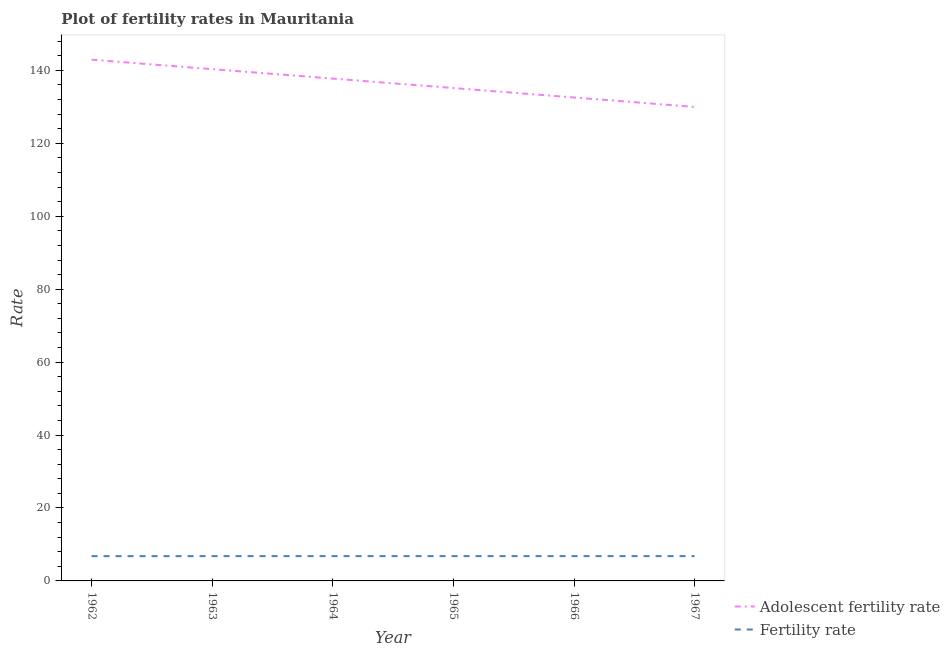Is the number of lines equal to the number of legend labels?
Ensure brevity in your answer.  Yes. What is the adolescent fertility rate in 1966?
Offer a terse response. 132.57. Across all years, what is the maximum fertility rate?
Give a very brief answer. 6.8. Across all years, what is the minimum fertility rate?
Your answer should be compact. 6.79. In which year was the adolescent fertility rate maximum?
Your answer should be compact. 1962. In which year was the adolescent fertility rate minimum?
Provide a succinct answer. 1967. What is the total adolescent fertility rate in the graph?
Your response must be concise. 818.74. What is the difference between the adolescent fertility rate in 1962 and that in 1963?
Make the answer very short. 2.59. What is the difference between the fertility rate in 1967 and the adolescent fertility rate in 1962?
Your answer should be very brief. -136.13. What is the average fertility rate per year?
Offer a terse response. 6.8. In the year 1962, what is the difference between the fertility rate and adolescent fertility rate?
Make the answer very short. -136.14. What is the ratio of the fertility rate in 1962 to that in 1963?
Your response must be concise. 1. What is the difference between the highest and the second highest fertility rate?
Your answer should be compact. 0. What is the difference between the highest and the lowest fertility rate?
Your answer should be compact. 0.01. Is the adolescent fertility rate strictly less than the fertility rate over the years?
Provide a short and direct response. No. How many years are there in the graph?
Your response must be concise. 6. Are the values on the major ticks of Y-axis written in scientific E-notation?
Give a very brief answer. No. Does the graph contain any zero values?
Offer a very short reply. No. Where does the legend appear in the graph?
Keep it short and to the point. Bottom right. What is the title of the graph?
Provide a succinct answer. Plot of fertility rates in Mauritania. Does "National Visitors" appear as one of the legend labels in the graph?
Provide a succinct answer. No. What is the label or title of the Y-axis?
Provide a short and direct response. Rate. What is the Rate of Adolescent fertility rate in 1962?
Make the answer very short. 142.93. What is the Rate in Fertility rate in 1962?
Provide a succinct answer. 6.79. What is the Rate in Adolescent fertility rate in 1963?
Keep it short and to the point. 140.34. What is the Rate of Fertility rate in 1963?
Offer a very short reply. 6.8. What is the Rate in Adolescent fertility rate in 1964?
Ensure brevity in your answer.  137.75. What is the Rate of Fertility rate in 1964?
Provide a succinct answer. 6.8. What is the Rate of Adolescent fertility rate in 1965?
Provide a succinct answer. 135.16. What is the Rate in Fertility rate in 1965?
Provide a succinct answer. 6.8. What is the Rate in Adolescent fertility rate in 1966?
Offer a very short reply. 132.57. What is the Rate in Fertility rate in 1966?
Your answer should be compact. 6.8. What is the Rate in Adolescent fertility rate in 1967?
Ensure brevity in your answer.  129.98. What is the Rate of Fertility rate in 1967?
Your response must be concise. 6.8. Across all years, what is the maximum Rate in Adolescent fertility rate?
Your answer should be compact. 142.93. Across all years, what is the maximum Rate in Fertility rate?
Your response must be concise. 6.8. Across all years, what is the minimum Rate of Adolescent fertility rate?
Offer a terse response. 129.98. Across all years, what is the minimum Rate in Fertility rate?
Give a very brief answer. 6.79. What is the total Rate in Adolescent fertility rate in the graph?
Offer a very short reply. 818.74. What is the total Rate in Fertility rate in the graph?
Keep it short and to the point. 40.79. What is the difference between the Rate of Adolescent fertility rate in 1962 and that in 1963?
Make the answer very short. 2.59. What is the difference between the Rate in Fertility rate in 1962 and that in 1963?
Provide a short and direct response. -0. What is the difference between the Rate of Adolescent fertility rate in 1962 and that in 1964?
Ensure brevity in your answer.  5.18. What is the difference between the Rate of Fertility rate in 1962 and that in 1964?
Provide a short and direct response. -0.01. What is the difference between the Rate in Adolescent fertility rate in 1962 and that in 1965?
Provide a short and direct response. 7.77. What is the difference between the Rate in Fertility rate in 1962 and that in 1965?
Your response must be concise. -0.01. What is the difference between the Rate in Adolescent fertility rate in 1962 and that in 1966?
Your answer should be compact. 10.36. What is the difference between the Rate of Fertility rate in 1962 and that in 1966?
Ensure brevity in your answer.  -0. What is the difference between the Rate of Adolescent fertility rate in 1962 and that in 1967?
Make the answer very short. 12.95. What is the difference between the Rate in Fertility rate in 1962 and that in 1967?
Offer a terse response. -0. What is the difference between the Rate in Adolescent fertility rate in 1963 and that in 1964?
Offer a terse response. 2.59. What is the difference between the Rate in Fertility rate in 1963 and that in 1964?
Keep it short and to the point. -0. What is the difference between the Rate of Adolescent fertility rate in 1963 and that in 1965?
Ensure brevity in your answer.  5.18. What is the difference between the Rate in Fertility rate in 1963 and that in 1965?
Give a very brief answer. -0. What is the difference between the Rate of Adolescent fertility rate in 1963 and that in 1966?
Provide a succinct answer. 7.77. What is the difference between the Rate in Adolescent fertility rate in 1963 and that in 1967?
Ensure brevity in your answer.  10.36. What is the difference between the Rate in Adolescent fertility rate in 1964 and that in 1965?
Your answer should be very brief. 2.59. What is the difference between the Rate in Fertility rate in 1964 and that in 1965?
Your response must be concise. 0. What is the difference between the Rate in Adolescent fertility rate in 1964 and that in 1966?
Your answer should be very brief. 5.18. What is the difference between the Rate in Fertility rate in 1964 and that in 1966?
Make the answer very short. 0. What is the difference between the Rate in Adolescent fertility rate in 1964 and that in 1967?
Your answer should be compact. 7.77. What is the difference between the Rate of Adolescent fertility rate in 1965 and that in 1966?
Offer a terse response. 2.59. What is the difference between the Rate in Fertility rate in 1965 and that in 1966?
Keep it short and to the point. 0. What is the difference between the Rate in Adolescent fertility rate in 1965 and that in 1967?
Offer a terse response. 5.18. What is the difference between the Rate in Adolescent fertility rate in 1966 and that in 1967?
Your response must be concise. 2.59. What is the difference between the Rate of Adolescent fertility rate in 1962 and the Rate of Fertility rate in 1963?
Your answer should be very brief. 136.13. What is the difference between the Rate in Adolescent fertility rate in 1962 and the Rate in Fertility rate in 1964?
Offer a terse response. 136.13. What is the difference between the Rate in Adolescent fertility rate in 1962 and the Rate in Fertility rate in 1965?
Ensure brevity in your answer.  136.13. What is the difference between the Rate in Adolescent fertility rate in 1962 and the Rate in Fertility rate in 1966?
Keep it short and to the point. 136.13. What is the difference between the Rate in Adolescent fertility rate in 1962 and the Rate in Fertility rate in 1967?
Your answer should be very brief. 136.13. What is the difference between the Rate of Adolescent fertility rate in 1963 and the Rate of Fertility rate in 1964?
Ensure brevity in your answer.  133.54. What is the difference between the Rate of Adolescent fertility rate in 1963 and the Rate of Fertility rate in 1965?
Offer a very short reply. 133.54. What is the difference between the Rate of Adolescent fertility rate in 1963 and the Rate of Fertility rate in 1966?
Give a very brief answer. 133.54. What is the difference between the Rate in Adolescent fertility rate in 1963 and the Rate in Fertility rate in 1967?
Provide a short and direct response. 133.54. What is the difference between the Rate of Adolescent fertility rate in 1964 and the Rate of Fertility rate in 1965?
Provide a succinct answer. 130.95. What is the difference between the Rate of Adolescent fertility rate in 1964 and the Rate of Fertility rate in 1966?
Give a very brief answer. 130.95. What is the difference between the Rate of Adolescent fertility rate in 1964 and the Rate of Fertility rate in 1967?
Give a very brief answer. 130.95. What is the difference between the Rate in Adolescent fertility rate in 1965 and the Rate in Fertility rate in 1966?
Provide a short and direct response. 128.36. What is the difference between the Rate of Adolescent fertility rate in 1965 and the Rate of Fertility rate in 1967?
Provide a short and direct response. 128.36. What is the difference between the Rate in Adolescent fertility rate in 1966 and the Rate in Fertility rate in 1967?
Offer a terse response. 125.77. What is the average Rate in Adolescent fertility rate per year?
Provide a succinct answer. 136.46. What is the average Rate in Fertility rate per year?
Offer a terse response. 6.8. In the year 1962, what is the difference between the Rate of Adolescent fertility rate and Rate of Fertility rate?
Make the answer very short. 136.14. In the year 1963, what is the difference between the Rate in Adolescent fertility rate and Rate in Fertility rate?
Give a very brief answer. 133.54. In the year 1964, what is the difference between the Rate of Adolescent fertility rate and Rate of Fertility rate?
Give a very brief answer. 130.95. In the year 1965, what is the difference between the Rate in Adolescent fertility rate and Rate in Fertility rate?
Offer a very short reply. 128.36. In the year 1966, what is the difference between the Rate of Adolescent fertility rate and Rate of Fertility rate?
Make the answer very short. 125.77. In the year 1967, what is the difference between the Rate in Adolescent fertility rate and Rate in Fertility rate?
Your response must be concise. 123.18. What is the ratio of the Rate of Adolescent fertility rate in 1962 to that in 1963?
Your answer should be very brief. 1.02. What is the ratio of the Rate in Fertility rate in 1962 to that in 1963?
Keep it short and to the point. 1. What is the ratio of the Rate of Adolescent fertility rate in 1962 to that in 1964?
Your answer should be very brief. 1.04. What is the ratio of the Rate of Adolescent fertility rate in 1962 to that in 1965?
Your answer should be very brief. 1.06. What is the ratio of the Rate in Fertility rate in 1962 to that in 1965?
Provide a short and direct response. 1. What is the ratio of the Rate of Adolescent fertility rate in 1962 to that in 1966?
Ensure brevity in your answer.  1.08. What is the ratio of the Rate in Fertility rate in 1962 to that in 1966?
Provide a short and direct response. 1. What is the ratio of the Rate of Adolescent fertility rate in 1962 to that in 1967?
Give a very brief answer. 1.1. What is the ratio of the Rate in Fertility rate in 1962 to that in 1967?
Keep it short and to the point. 1. What is the ratio of the Rate in Adolescent fertility rate in 1963 to that in 1964?
Offer a very short reply. 1.02. What is the ratio of the Rate of Adolescent fertility rate in 1963 to that in 1965?
Make the answer very short. 1.04. What is the ratio of the Rate in Fertility rate in 1963 to that in 1965?
Offer a very short reply. 1. What is the ratio of the Rate in Adolescent fertility rate in 1963 to that in 1966?
Keep it short and to the point. 1.06. What is the ratio of the Rate of Fertility rate in 1963 to that in 1966?
Provide a short and direct response. 1. What is the ratio of the Rate in Adolescent fertility rate in 1963 to that in 1967?
Offer a very short reply. 1.08. What is the ratio of the Rate of Fertility rate in 1963 to that in 1967?
Offer a terse response. 1. What is the ratio of the Rate in Adolescent fertility rate in 1964 to that in 1965?
Give a very brief answer. 1.02. What is the ratio of the Rate in Fertility rate in 1964 to that in 1965?
Give a very brief answer. 1. What is the ratio of the Rate in Adolescent fertility rate in 1964 to that in 1966?
Ensure brevity in your answer.  1.04. What is the ratio of the Rate of Adolescent fertility rate in 1964 to that in 1967?
Make the answer very short. 1.06. What is the ratio of the Rate of Adolescent fertility rate in 1965 to that in 1966?
Keep it short and to the point. 1.02. What is the ratio of the Rate in Fertility rate in 1965 to that in 1966?
Keep it short and to the point. 1. What is the ratio of the Rate of Adolescent fertility rate in 1965 to that in 1967?
Provide a succinct answer. 1.04. What is the ratio of the Rate of Fertility rate in 1965 to that in 1967?
Keep it short and to the point. 1. What is the ratio of the Rate in Adolescent fertility rate in 1966 to that in 1967?
Provide a short and direct response. 1.02. What is the difference between the highest and the second highest Rate of Adolescent fertility rate?
Ensure brevity in your answer.  2.59. What is the difference between the highest and the lowest Rate of Adolescent fertility rate?
Your answer should be compact. 12.95. What is the difference between the highest and the lowest Rate in Fertility rate?
Ensure brevity in your answer.  0.01. 